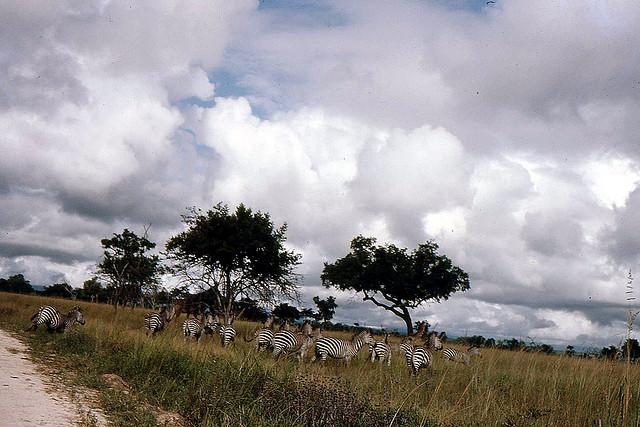Are the zebras in their natural habitat?
Give a very brief answer. Yes. What type of animals are pictured?
Quick response, please. Zebras. What animals are in the field?
Be succinct. Zebras. Is the grass dead?
Concise answer only. No. Does this neighborhood have telephone service?
Write a very short answer. No. Are there commercial crops in this picture?
Keep it brief. No. 